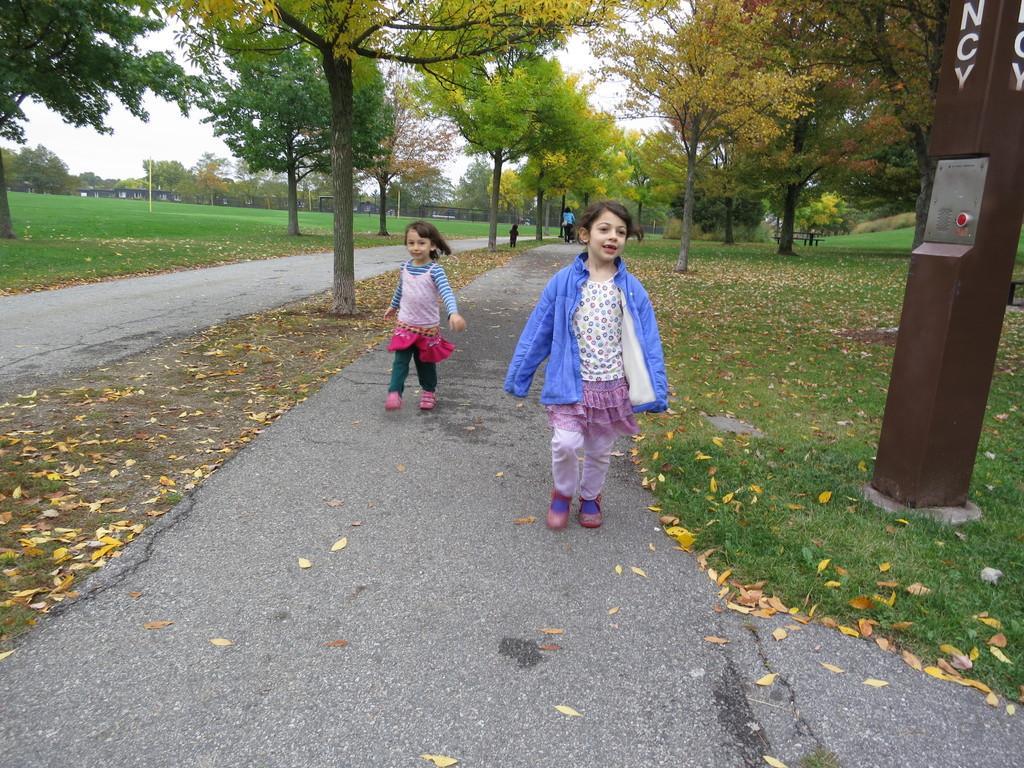Can you describe this image briefly? In this picture we can see two girls walking on the road, here we can see dried leaves, grass, object and in the background we can see people, trees, wall, sky. 